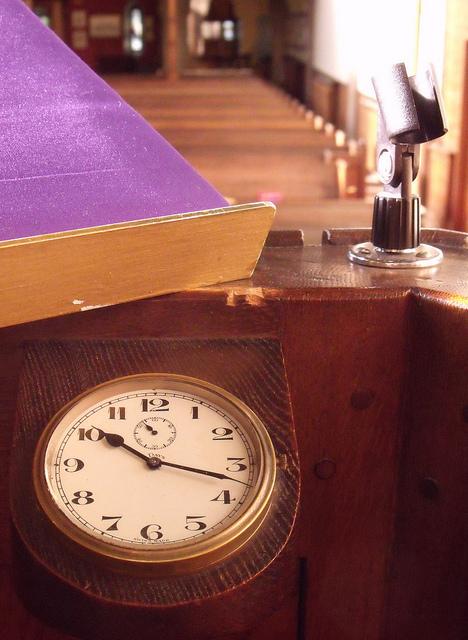What bright color is above the clock?
Answer briefly. Purple. How many clocks are there?
Quick response, please. 1. What time is it?
Concise answer only. 10:17. 